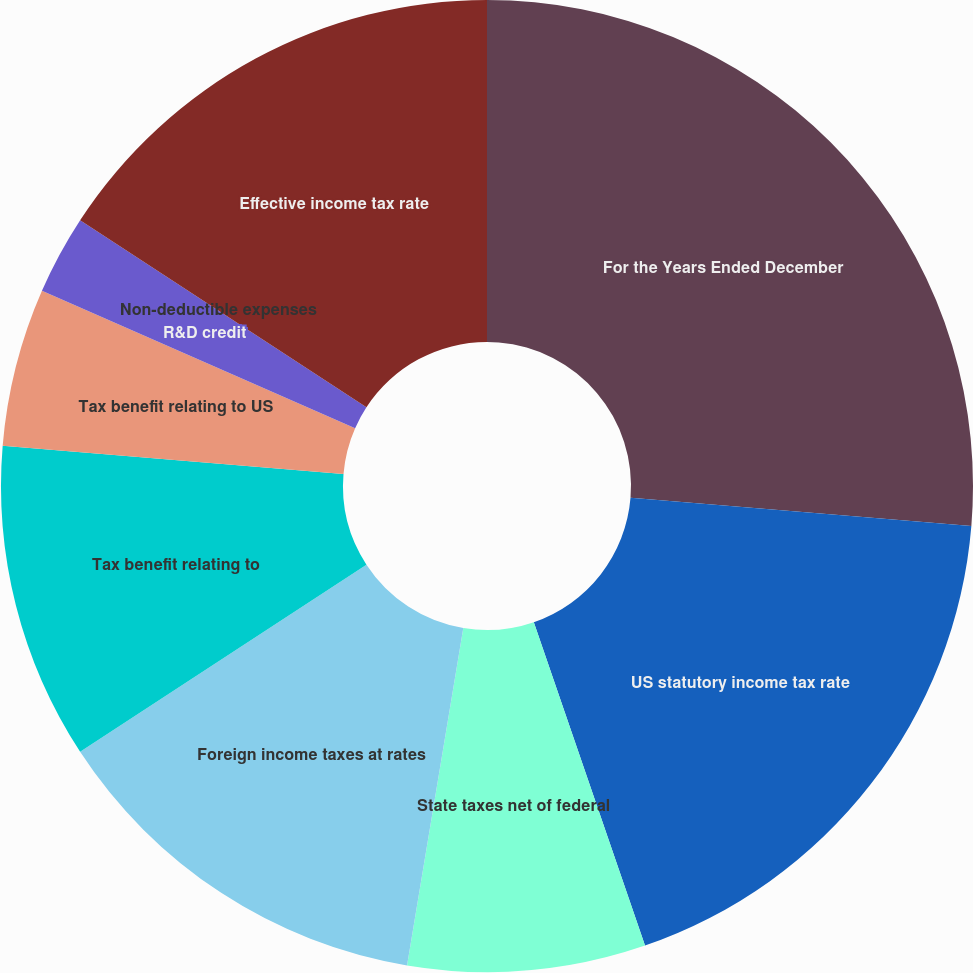<chart> <loc_0><loc_0><loc_500><loc_500><pie_chart><fcel>For the Years Ended December<fcel>US statutory income tax rate<fcel>State taxes net of federal<fcel>Foreign income taxes at rates<fcel>Tax benefit relating to<fcel>Tax benefit relating to US<fcel>R&D credit<fcel>Non-deductible expenses<fcel>Effective income tax rate<nl><fcel>26.31%<fcel>18.42%<fcel>7.9%<fcel>13.16%<fcel>10.53%<fcel>5.26%<fcel>2.63%<fcel>0.0%<fcel>15.79%<nl></chart> 